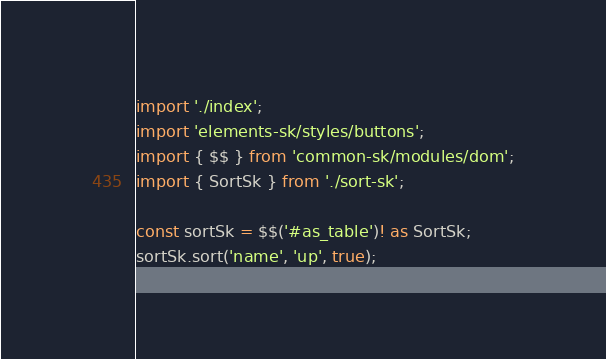<code> <loc_0><loc_0><loc_500><loc_500><_TypeScript_>import './index';
import 'elements-sk/styles/buttons';
import { $$ } from 'common-sk/modules/dom';
import { SortSk } from './sort-sk';

const sortSk = $$('#as_table')! as SortSk;
sortSk.sort('name', 'up', true);
</code> 